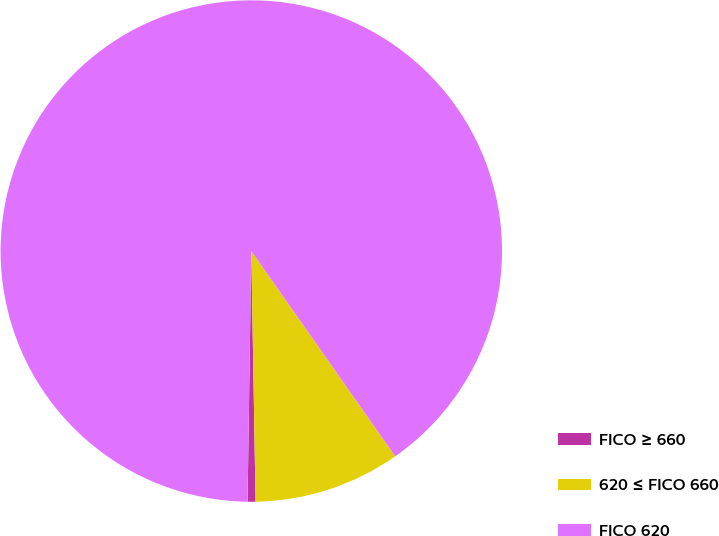<chart> <loc_0><loc_0><loc_500><loc_500><pie_chart><fcel>FICO ≥ 660<fcel>620 ≤ FICO 660<fcel>FICO 620<nl><fcel>0.51%<fcel>9.46%<fcel>90.04%<nl></chart> 